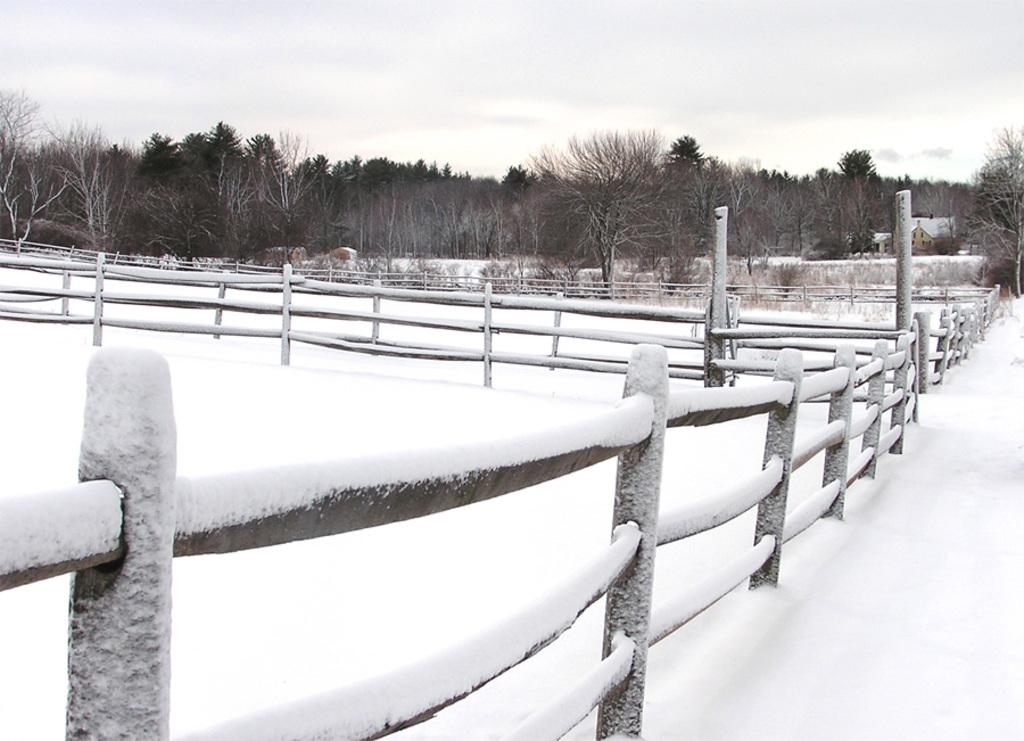What is covering the fences and ground in the image? There is snow on the fences and the ground in the image. What can be seen in the background of the image? There are trees and houses in the background of the image. What is visible in the sky in the background of the image? There are clouds in the sky in the background of the image. What type of juice is being served at the operation in the image? There is no juice or operation present in the image; it features snow-covered fences and ground with trees and houses in the background. 